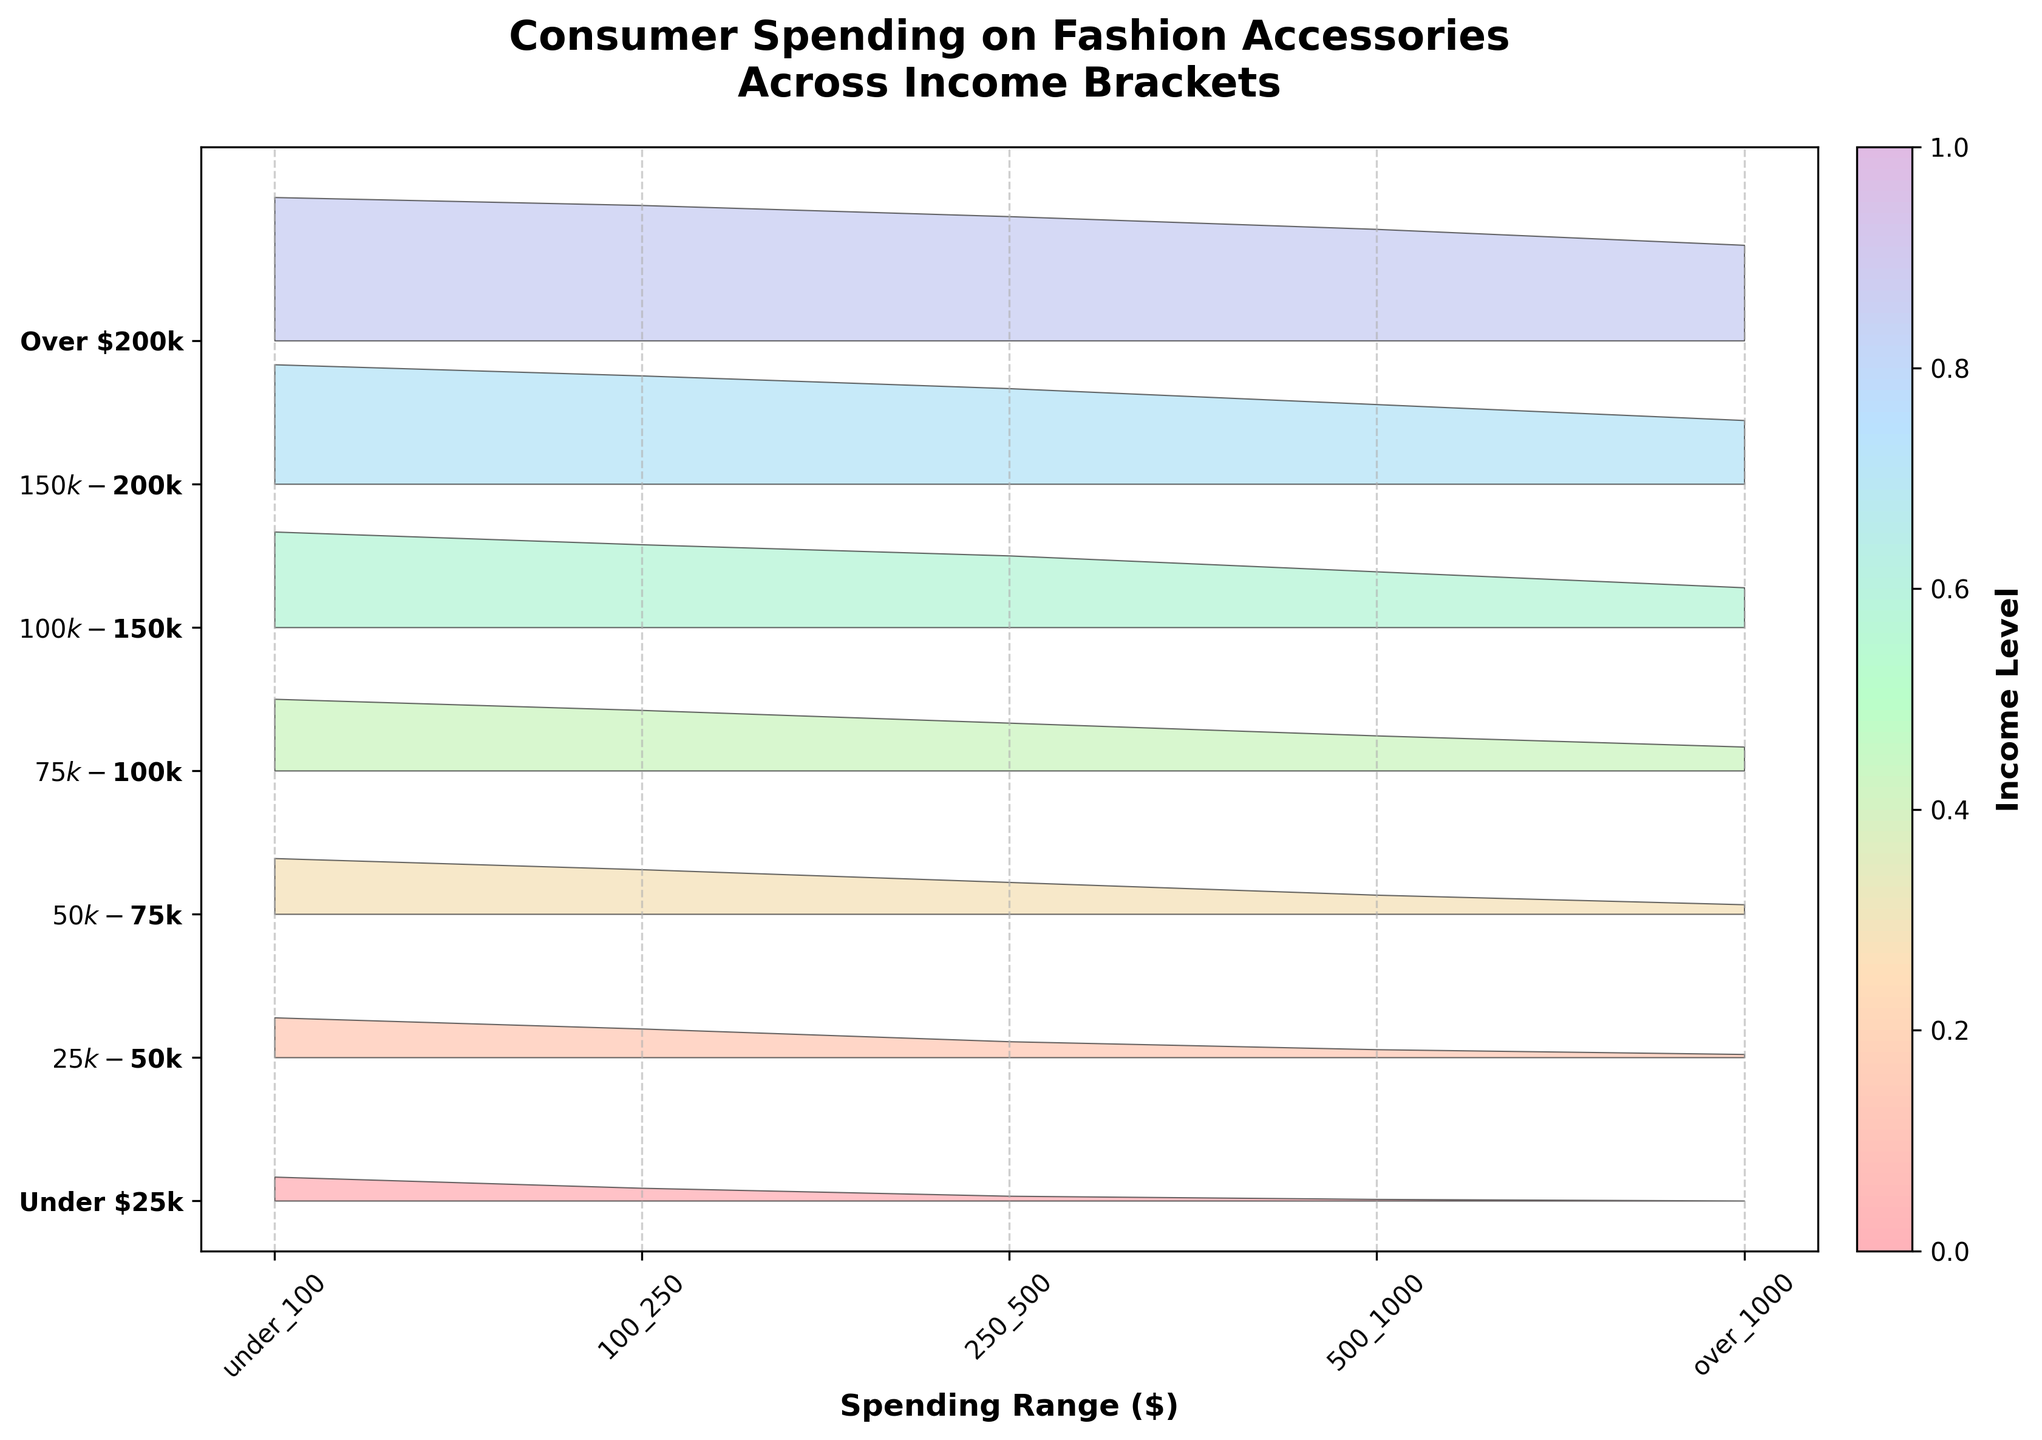what is the title of the plot? The title is usually located at the top center of the plot and provides a summary of what the plot is about.
Answer: Consumer Spending on Fashion Accessories Across Income Brackets What income bracket has the highest spending in the over $1000 category? Examine the over $1000 category and compare the values across different income brackets. The "Over $200k" bracket has the highest visual peak.
Answer: Over $200k Which income bracket has the most entries in the under $100 category? Look at the fill areas for the under $100 spending range and identify the income bracket with the tallest peak.
Answer: Over $200k What is the total spending in the $25k-$50k bracket across all categories? Sum the spending values for this bracket: 25 (under 100) + 18 (100-250) + 10 (250-500) + 5 (500-1000) + 2 (over 1000) = 60.
Answer: 60 How does the spending in the $75k-$100k bracket compare to the Under $25k bracket across the 500-1000 category? Subtract the spending in the Under $25k bracket from the $75k-$100k bracket in the 500-1000 range. 22 - 1 = 21.
Answer: 21 Is there any income bracket that doesn't spend in the over $1000 category? Verify if any income bracket has a value of 0 in the over $1000 spending category. The "Under $25k" bracket has 0 in this range.
Answer: Under $25k Which income bracket shows the steepest increase in spending from the 250-500 to the 500-1000 range? Compare the differences in spending between the 250-500 and 500-1000 ranges across all brackets. The most significant increase (from 30 to 22) is seen in the $75k-$100k bracket.
Answer: $75k-$100k What is the average spending in the over $1000 category? Sum of all over $1000 values: 0 + 2 + 6 + 15 + 25 + 40 + 60 = 148. There are 7 brackets, so average is 148/7 ≈ 21.14.
Answer: 21.14 Which income bracket has the most diversified spending across all categories? "Diversified spending" means more evenly spread. By visual inspection, the "Over $200k" bracket has high values spread across all categories.
Answer: Over $200k What color represents the highest income bracket? Check the plot's color gradient and associate the last color with the highest income bracket, which is "Over $200k".
Answer: A deep shade of the final gradient (depends on the colormap provided) 